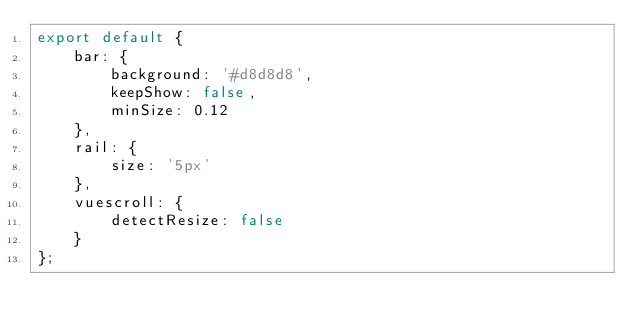<code> <loc_0><loc_0><loc_500><loc_500><_JavaScript_>export default {
    bar: {
        background: '#d8d8d8',
        keepShow: false,
        minSize: 0.12
    },
    rail: {
        size: '5px'
    },
    vuescroll: {
        detectResize: false
    }
};
</code> 